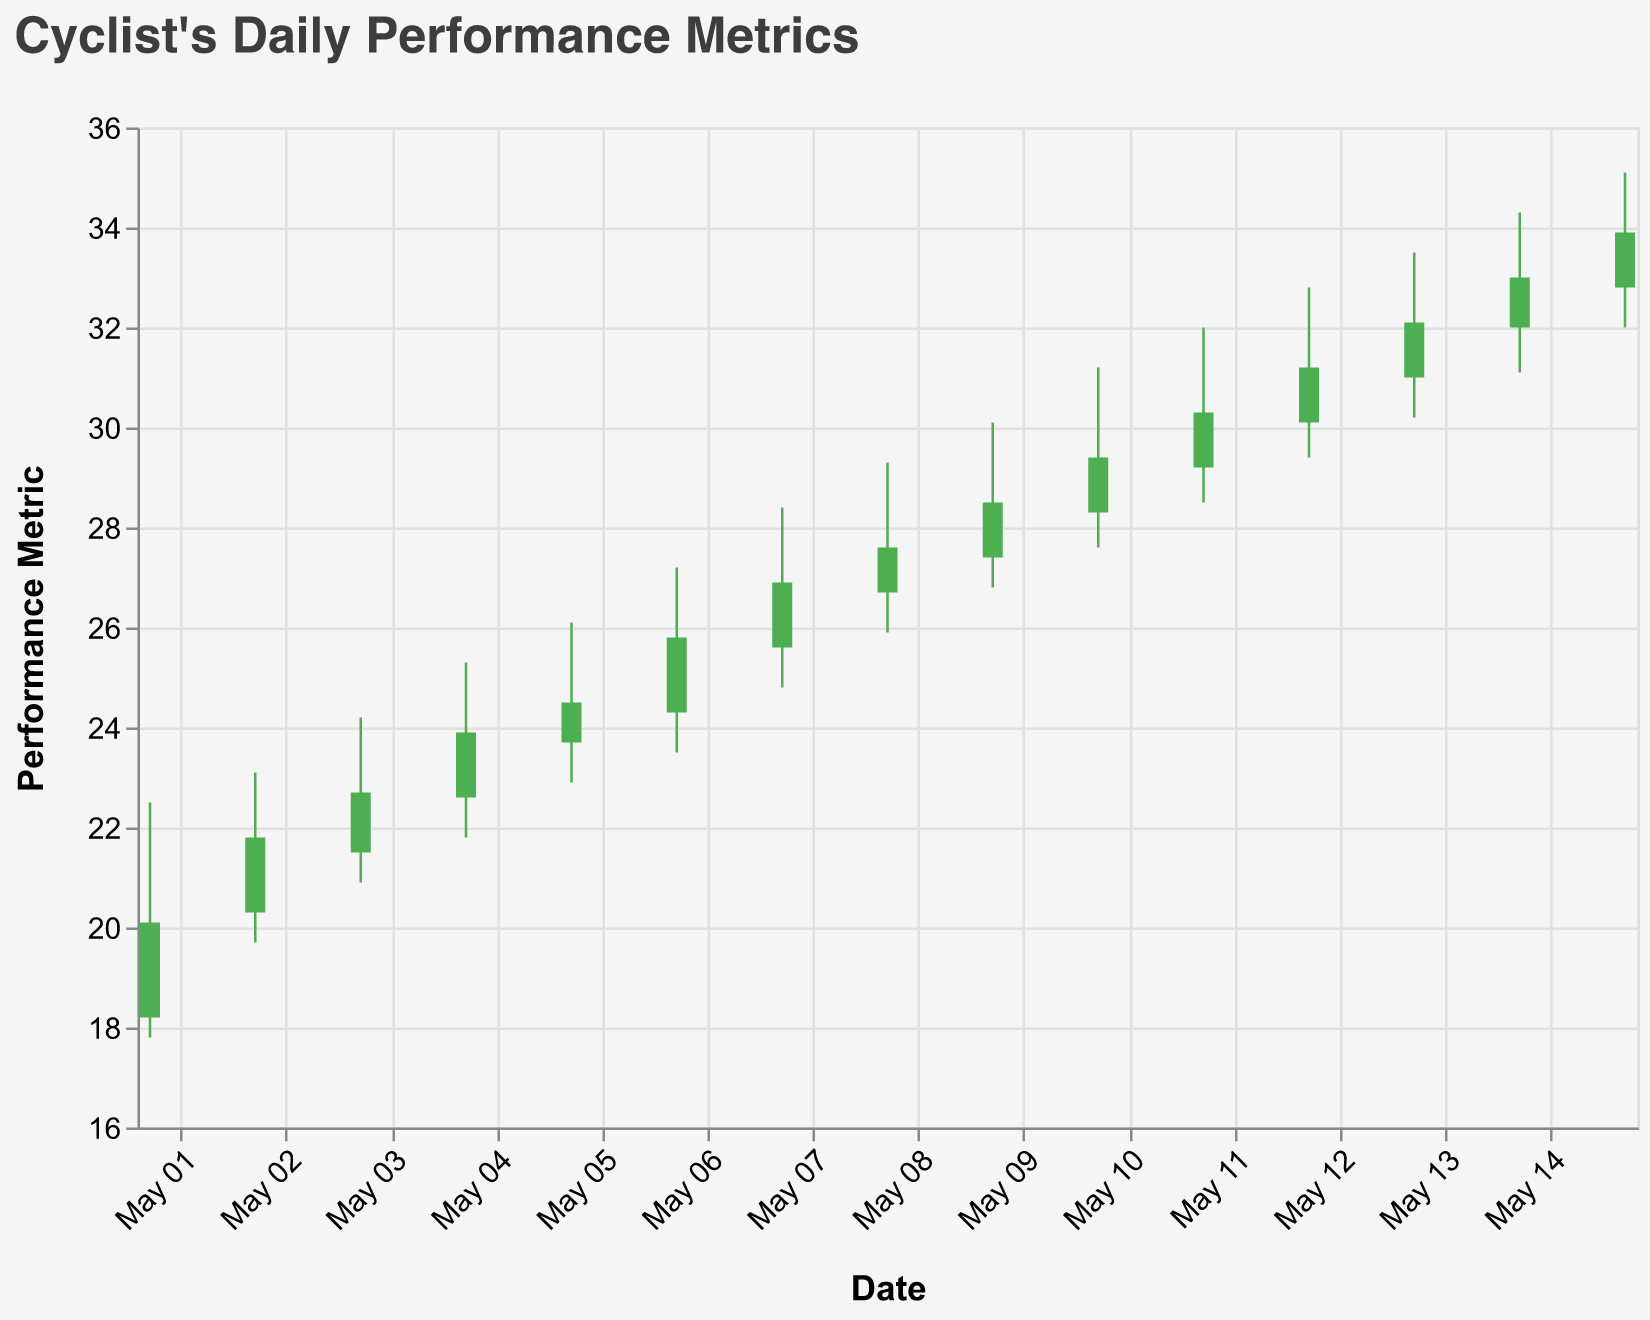What's the title of the chart? The title of the chart is displayed at the top and reads: "Cyclist's Daily Performance Metrics".
Answer: Cyclist's Daily Performance Metrics On what date do we see the highest "High" value for the performance metric? Look for the bar with the maximum extension on the y-axis under the "High" category. The highest "High" value is on "May 15" where it reaches 35.1.
Answer: May 15 How does the performance metric on May 03 compare to May 10 in terms of the "Close" value? Find and compare the "Close" value for both dates. On May 03, the "Close" value is 22.7; on May 10, it is 29.4. Therefore, the "Close" value on May 10 is higher.
Answer: May 10 is higher What dates have "Close" values greater than 30? Check the data points where the "Close" value exceeds 30. These dates are "May 11", "May 12", "May 13", "May 14", and "May 15".
Answer: May 11, May 12, May 13, May 14, May 15 What is the difference between the "High" and "Low" values on May 05? Calculate the difference by subtracting the "Low" value from the "High" value on May 05. High is 26.1 and Low is 22.9, so the difference is 26.1 - 22.9 = 3.2.
Answer: 3.2 Which date has the smallest range between the "High" and "Low" values? The range is calculated by subtracting the "Low" from the "High" value. Compare the ranges for each date and identify the smallest one. The smallest range is on May 02 where the difference is 23.1 - 19.7 = 3.4.
Answer: May 02 What can you infer from the color of the bars? The color of the bars indicates whether the "Close" value is higher (green) or lower (red) than the "Open" value. If it's green, the cyclist's performance improved from the start to the end of the day. If it's red, the performance declined.
Answer: Indicates improvement or decline How many days show an improvement in performance based on the bar colors? Count the number of green bars, which indicate days where the "Close" value is higher than the "Open" value. There are 14 such days.
Answer: 14 What is the average "Close" value over the entire period? Sum up all "Close" values and then divide by the number of days, i.e., (20.1 + 21.8 + 22.7 + 23.9 + 24.5 + 25.8 + 26.9 + 27.6 + 28.5 + 29.4 + 30.3 + 31.2 + 32.1 + 33.0 + 33.9)/15. The total is 432.7, and the average is 432.7 / 15 = 28.85.
Answer: 28.85 